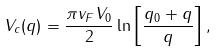Convert formula to latex. <formula><loc_0><loc_0><loc_500><loc_500>V _ { c } ( q ) = \frac { \pi v _ { F } V _ { 0 } } { 2 } \ln \left [ \frac { q _ { 0 } + q } { q } \right ] ,</formula> 